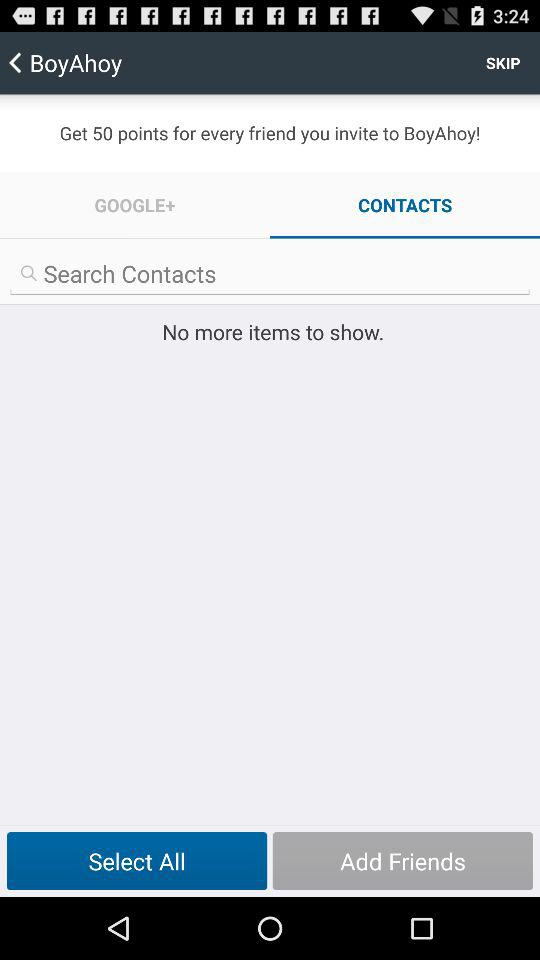Are there any items to show? There are no items to show. 